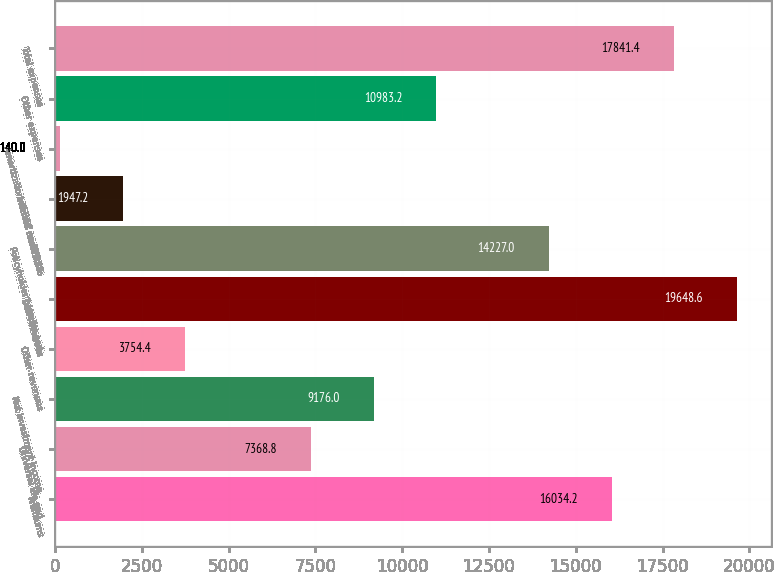Convert chart. <chart><loc_0><loc_0><loc_500><loc_500><bar_chart><fcel>Premiums<fcel>Universal life and<fcel>Net investment income<fcel>Other revenues<fcel>Total revenues<fcel>Policyholder benefits and<fcel>Interest credited to<fcel>Amortization of DAC and VOBA<fcel>Other expenses<fcel>Total expenses<nl><fcel>16034.2<fcel>7368.8<fcel>9176<fcel>3754.4<fcel>19648.6<fcel>14227<fcel>1947.2<fcel>140<fcel>10983.2<fcel>17841.4<nl></chart> 